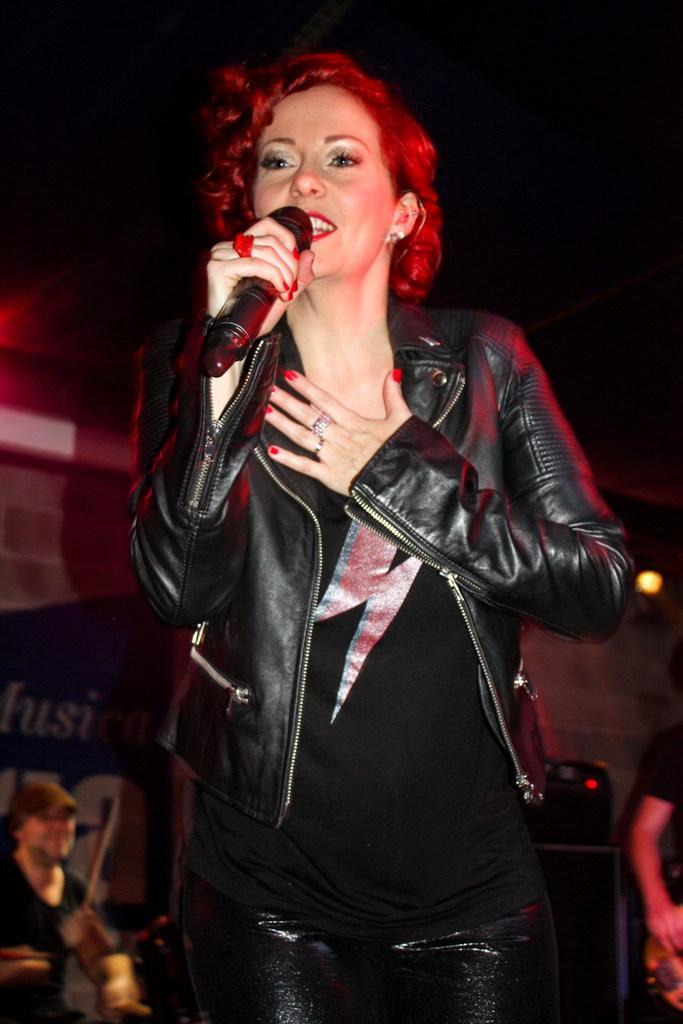In one or two sentences, can you explain what this image depicts? In this picture we can see woman holding mic in her hand and talking and in background we can see man hitting drums, wall, light, some person holding guitar. 